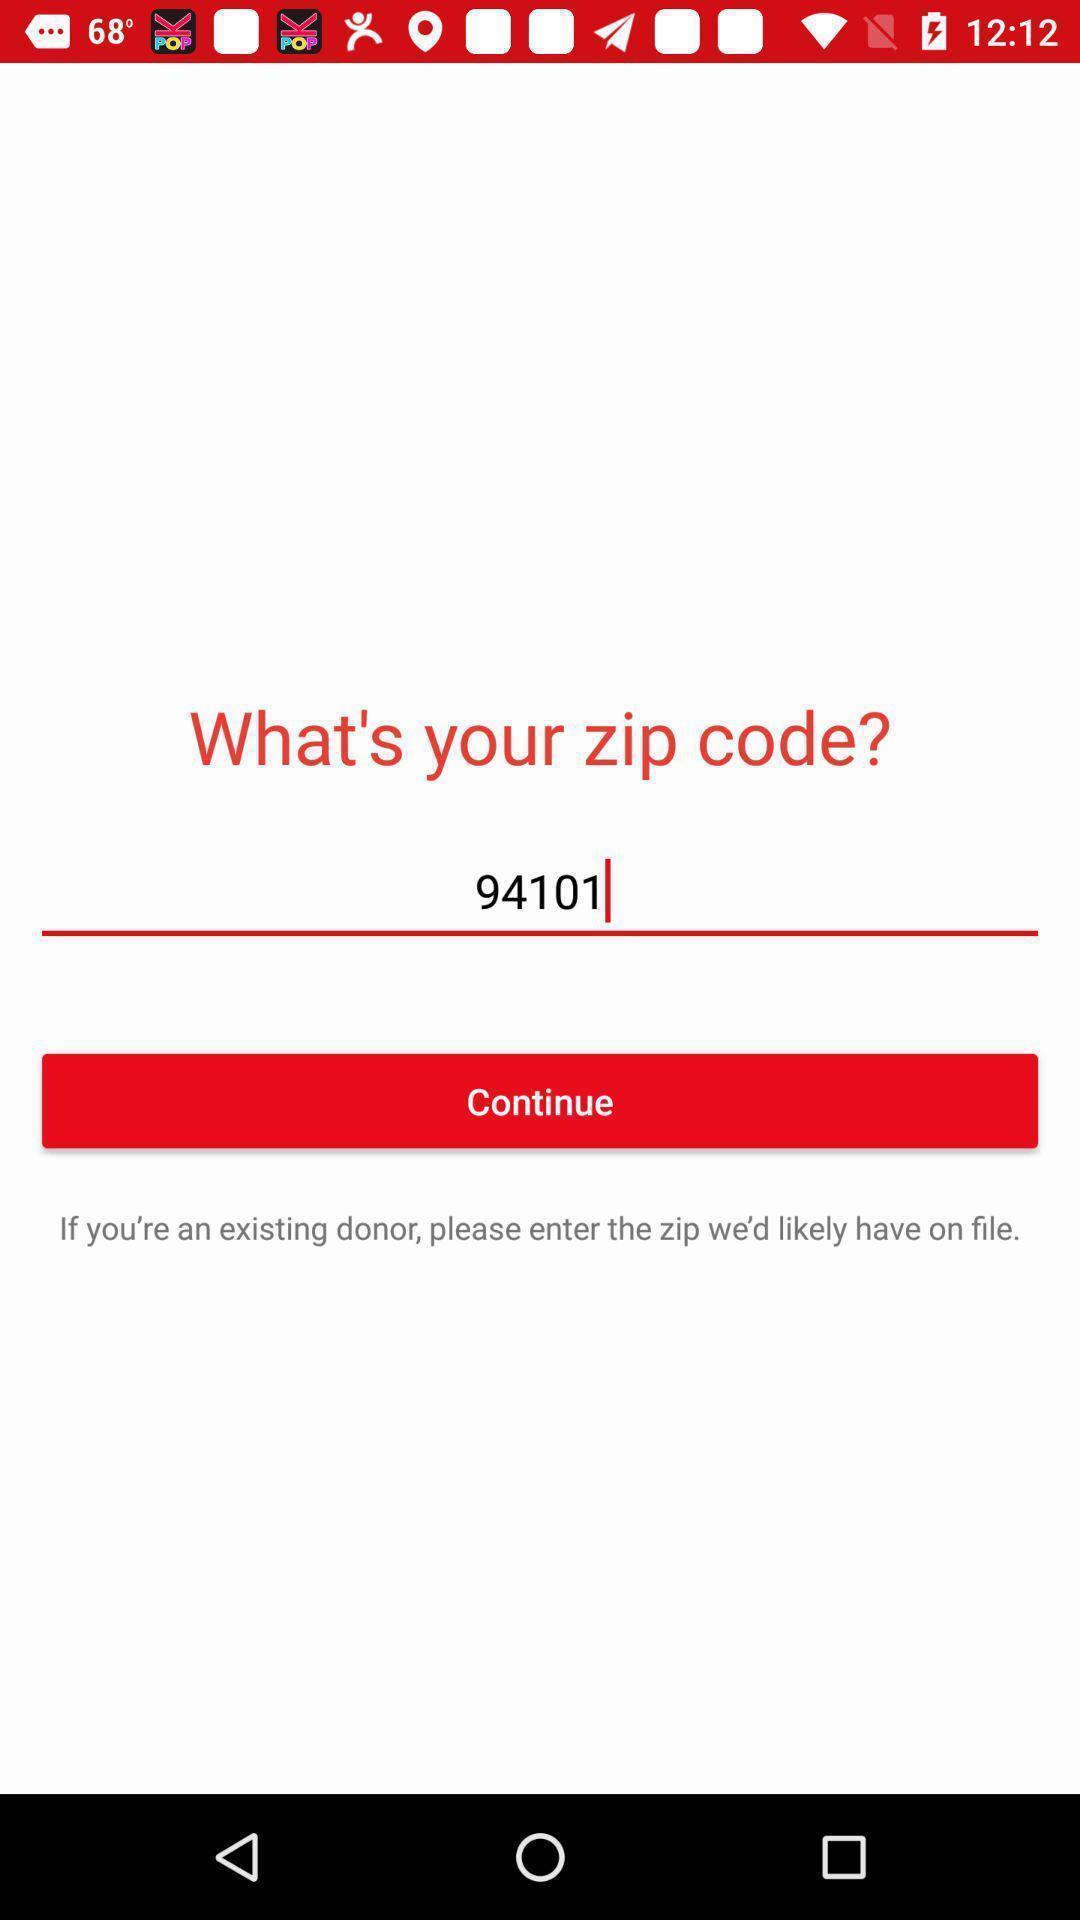Please provide a description for this image. Page showing option enter to zip code. 